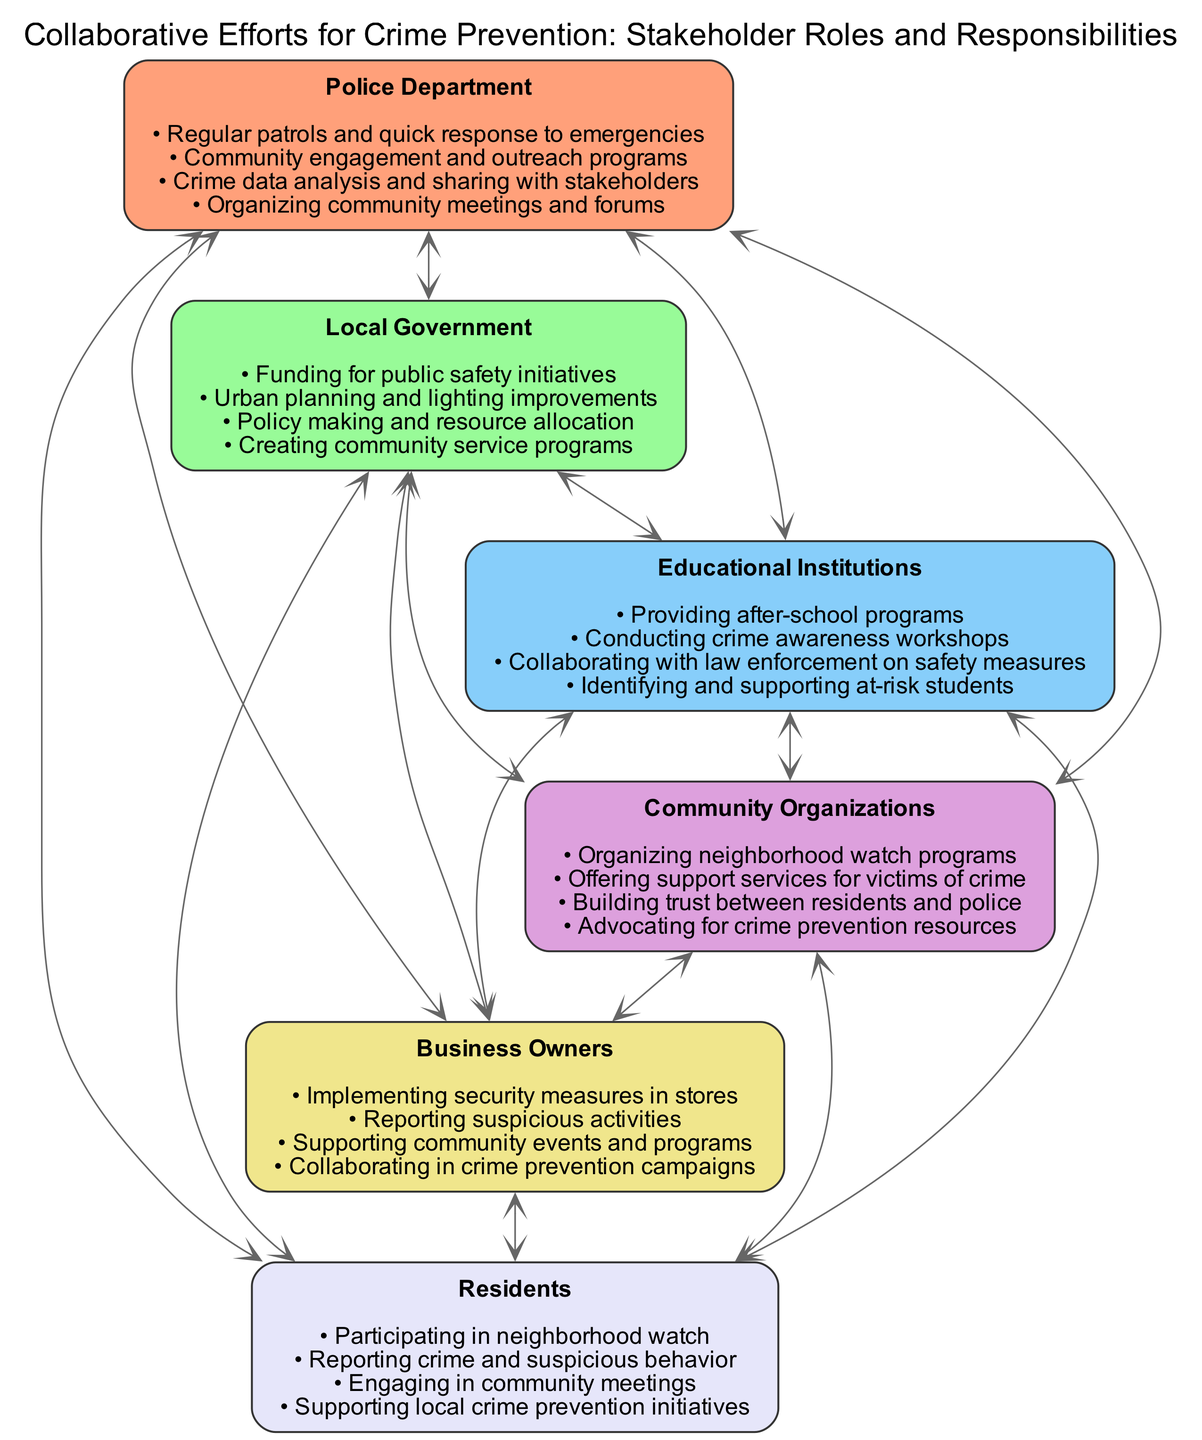What are the responsibilities of the Police Department? The Police Department has multiple responsibilities listed in the diagram, which include regular patrols, community engagement, crime data analysis, and organizing community meetings.
Answer: Regular patrols and quick response to emergencies, Community engagement and outreach programs, Crime data analysis and sharing with stakeholders, Organizing community meetings and forums How many stakeholders are represented in the diagram? The diagram features six distinct stakeholders including the Police Department, Local Government, Educational Institutions, Community Organizations, Business Owners, and Residents. This is determined by counting the number of blocks presented.
Answer: 6 Which stakeholder is responsible for urban planning? Urban planning and lighting improvements are responsibilities assigned to the Local Government as outlined in their block.
Answer: Local Government What is a responsibility shared by Community Organizations and Residents? Both Community Organizations and Residents are involved in activities that enhance community safety and support, specifically through building trust and participating in programs. This involves looking at the overlaps in their responsibilities as depicted.
Answer: Building trust between residents and police What type of programs do Educational Institutions provide to help crime prevention? Educational Institutions focus on crime prevention by conducting various programs including after-school programs and awareness workshops. To answer, we look directly at the responsibilities of the Educational Institutions which mention these specific initiatives.
Answer: Providing after-school programs How do Business Owners contribute to crime prevention efforts? Business Owners implement security measures, report suspicious activities, support community events, and collaborate in crime prevention campaigns, reflecting a proactive role in community safety efforts. A review of their block will clarify these responsibilities.
Answer: Implementing security measures in stores Which two stakeholders have a direct connection in organizing community events? The two stakeholders directly connected in organizing community events are the Community Organizations and Business Owners. We identify this by examining their listed responsibilities related to community engagement and support.
Answer: Community Organizations, Business Owners What is the primary funding role of the Local Government in this diagram? The Local Government's primary funding role is to provide financial resources for public safety initiatives as specified in their responsibilities. This was determined by looking specifically at the funding-related task assigned to the Local Government.
Answer: Funding for public safety initiatives 